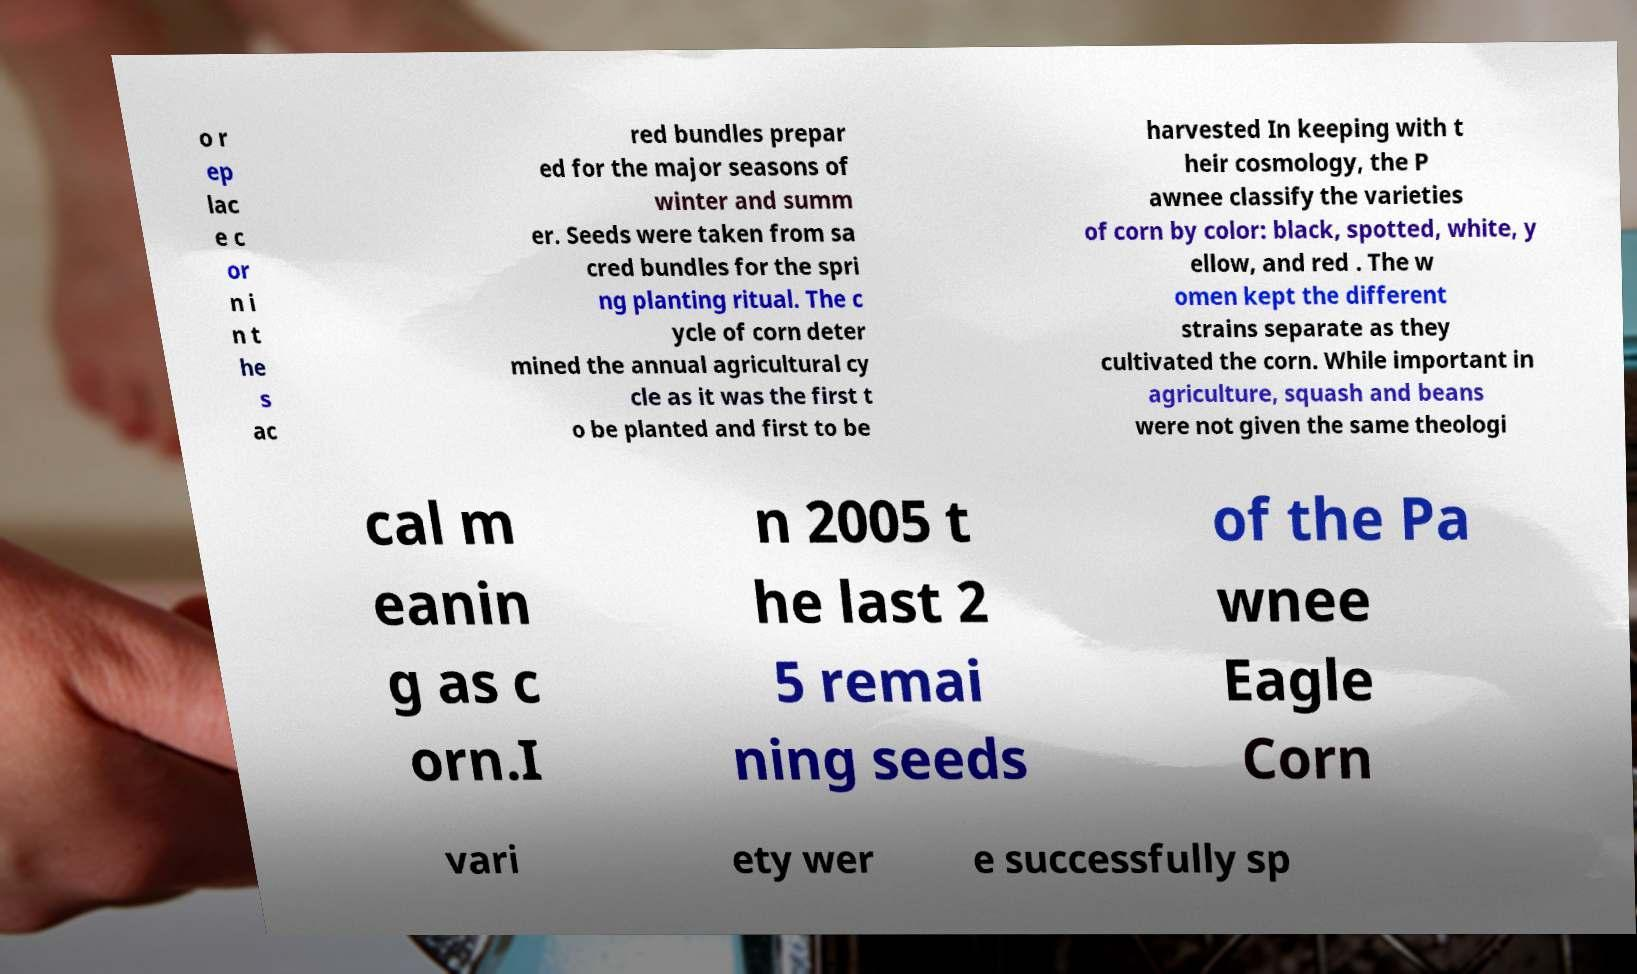What messages or text are displayed in this image? I need them in a readable, typed format. o r ep lac e c or n i n t he s ac red bundles prepar ed for the major seasons of winter and summ er. Seeds were taken from sa cred bundles for the spri ng planting ritual. The c ycle of corn deter mined the annual agricultural cy cle as it was the first t o be planted and first to be harvested In keeping with t heir cosmology, the P awnee classify the varieties of corn by color: black, spotted, white, y ellow, and red . The w omen kept the different strains separate as they cultivated the corn. While important in agriculture, squash and beans were not given the same theologi cal m eanin g as c orn.I n 2005 t he last 2 5 remai ning seeds of the Pa wnee Eagle Corn vari ety wer e successfully sp 